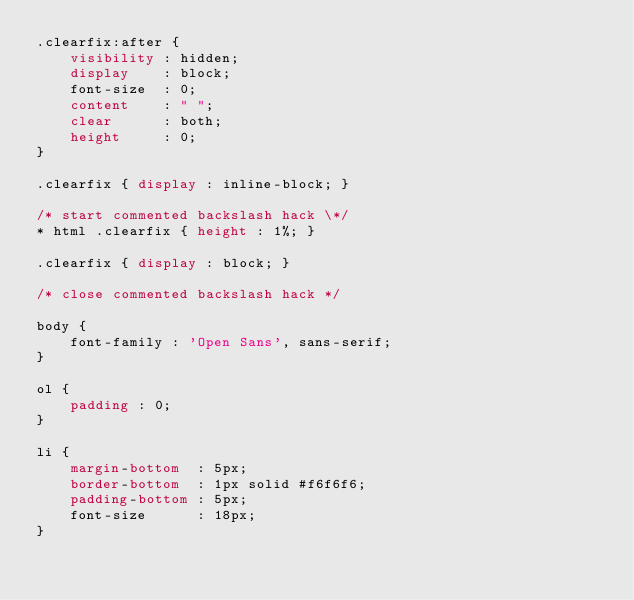<code> <loc_0><loc_0><loc_500><loc_500><_CSS_>.clearfix:after {
    visibility : hidden;
    display    : block;
    font-size  : 0;
    content    : " ";
    clear      : both;
    height     : 0;
}

.clearfix { display : inline-block; }

/* start commented backslash hack \*/
* html .clearfix { height : 1%; }

.clearfix { display : block; }

/* close commented backslash hack */

body {
    font-family : 'Open Sans', sans-serif;
}

ol {
    padding : 0;
}

li {
    margin-bottom  : 5px;
    border-bottom  : 1px solid #f6f6f6;
    padding-bottom : 5px;
    font-size      : 18px;
}</code> 